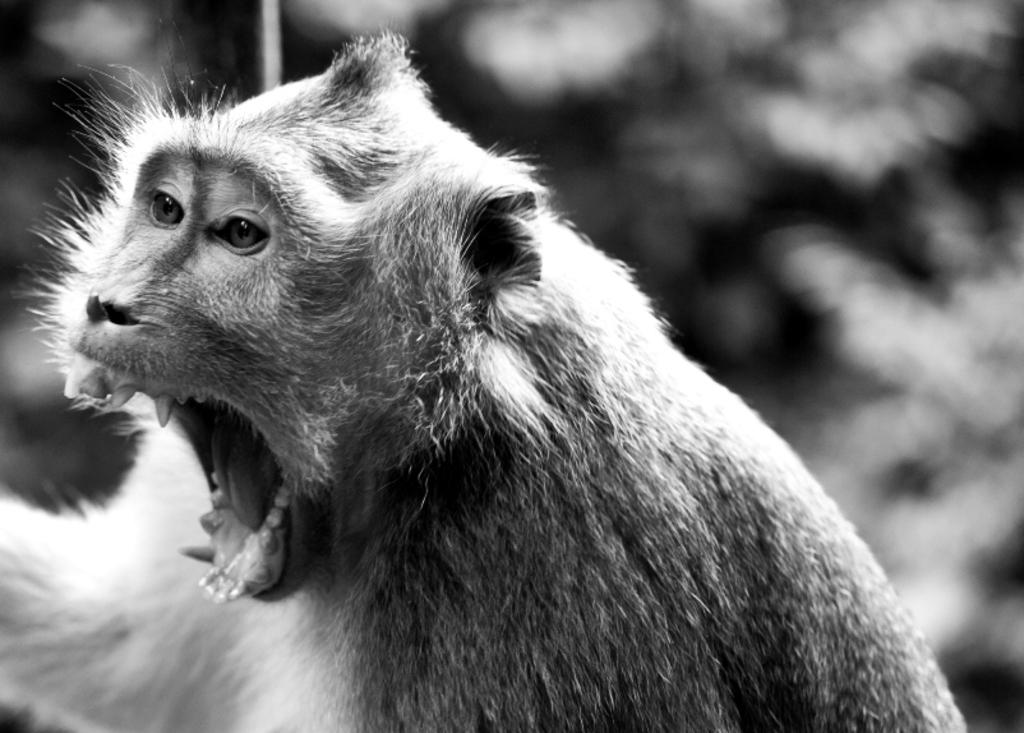What animal is present in the image? There is a monkey in the image. What is the color scheme of the image? The image is black and white. Can you describe the background of the image? There are blurry objects in the background of the image. How many pigs are visible in the image? There are no pigs present in the image; it features a monkey. What type of bun is being used to stretch the monkey's tail in the image? There is no bun or stretching action depicted in the image; it is a still photograph of a monkey. 